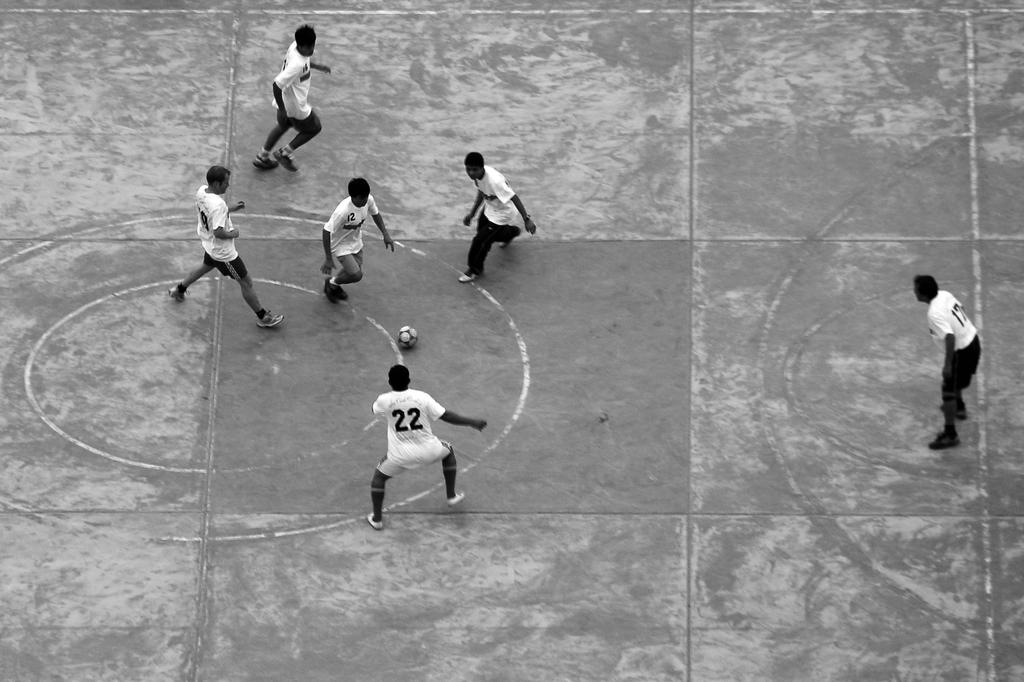How many people are in the image? There is a group of people in the image, but the exact number is not specified. What are the people in the image doing? The people are playing a game in the image. What object is involved in the game? There is a ball in the image. What is the color scheme of the image? The image is in black and white. What type of operation is being performed on the map in the image? There is no map or operation present in the image; it features a group of people playing a game with a ball. How many toes are visible on the people in the image? The number of toes visible on the people in the image is not specified, and their feet are not the focus of the image. 